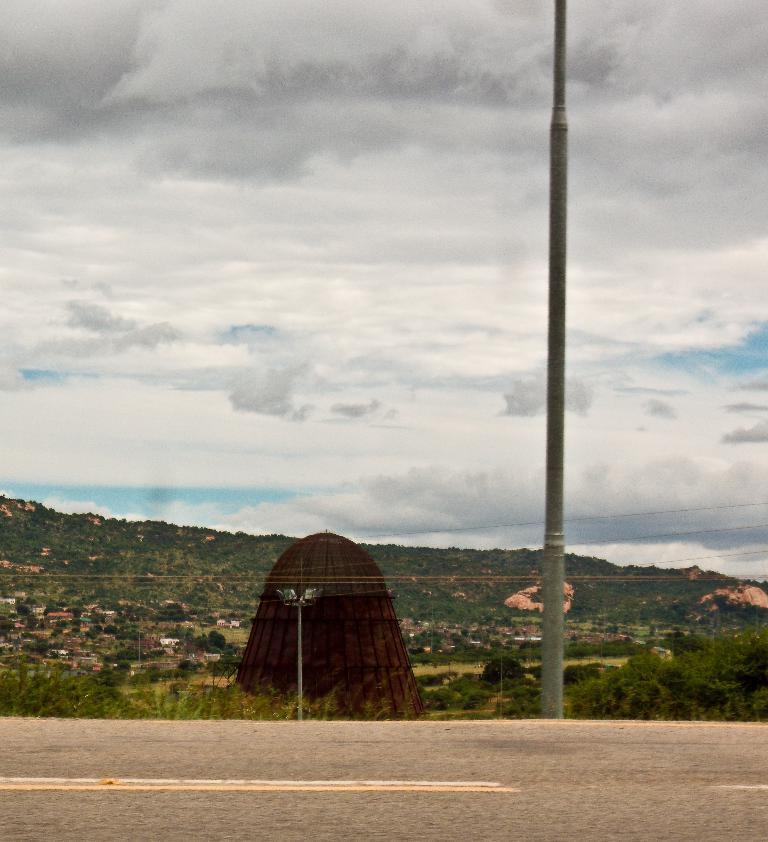Could you give a brief overview of what you see in this image? At the bottom we can see road,pole,grass,light pole,electrical wires. In the background there are bricks,houses,trees,grass and clouds in the sky. 